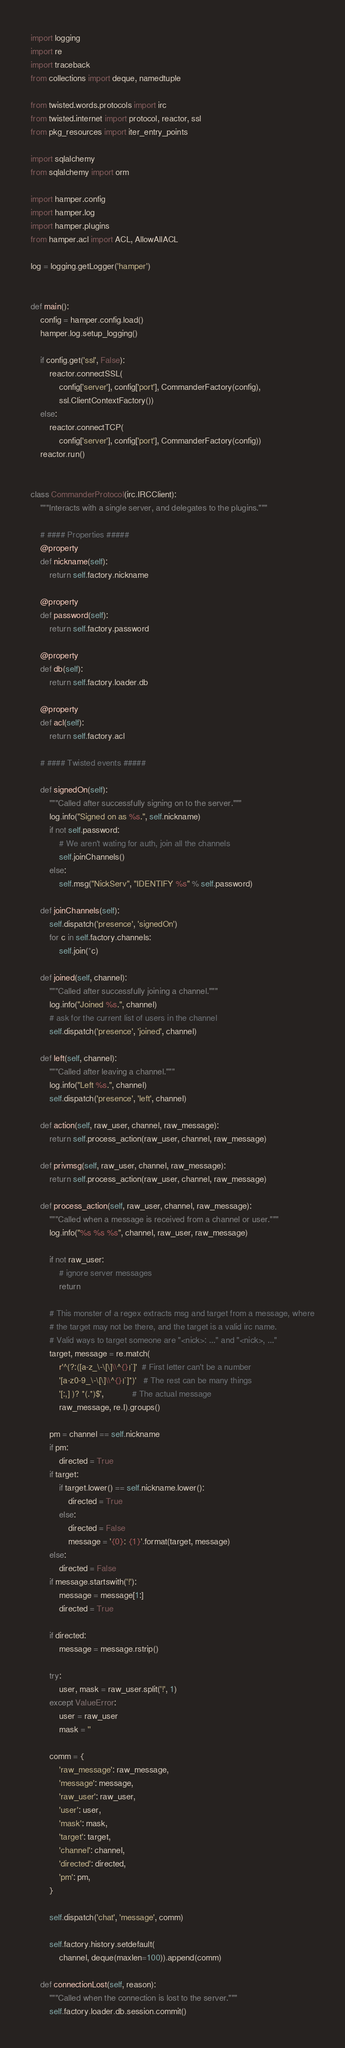Convert code to text. <code><loc_0><loc_0><loc_500><loc_500><_Python_>import logging
import re
import traceback
from collections import deque, namedtuple

from twisted.words.protocols import irc
from twisted.internet import protocol, reactor, ssl
from pkg_resources import iter_entry_points

import sqlalchemy
from sqlalchemy import orm

import hamper.config
import hamper.log
import hamper.plugins
from hamper.acl import ACL, AllowAllACL

log = logging.getLogger('hamper')


def main():
    config = hamper.config.load()
    hamper.log.setup_logging()

    if config.get('ssl', False):
        reactor.connectSSL(
            config['server'], config['port'], CommanderFactory(config),
            ssl.ClientContextFactory())
    else:
        reactor.connectTCP(
            config['server'], config['port'], CommanderFactory(config))
    reactor.run()


class CommanderProtocol(irc.IRCClient):
    """Interacts with a single server, and delegates to the plugins."""

    # #### Properties #####
    @property
    def nickname(self):
        return self.factory.nickname

    @property
    def password(self):
        return self.factory.password

    @property
    def db(self):
        return self.factory.loader.db

    @property
    def acl(self):
        return self.factory.acl

    # #### Twisted events #####

    def signedOn(self):
        """Called after successfully signing on to the server."""
        log.info("Signed on as %s.", self.nickname)
        if not self.password:
            # We aren't wating for auth, join all the channels
            self.joinChannels()
        else:
            self.msg("NickServ", "IDENTIFY %s" % self.password)

    def joinChannels(self):
        self.dispatch('presence', 'signedOn')
        for c in self.factory.channels:
            self.join(*c)

    def joined(self, channel):
        """Called after successfully joining a channel."""
        log.info("Joined %s.", channel)
        # ask for the current list of users in the channel
        self.dispatch('presence', 'joined', channel)

    def left(self, channel):
        """Called after leaving a channel."""
        log.info("Left %s.", channel)
        self.dispatch('presence', 'left', channel)

    def action(self, raw_user, channel, raw_message):
        return self.process_action(raw_user, channel, raw_message)

    def privmsg(self, raw_user, channel, raw_message):
        return self.process_action(raw_user, channel, raw_message)

    def process_action(self, raw_user, channel, raw_message):
        """Called when a message is received from a channel or user."""
        log.info("%s %s %s", channel, raw_user, raw_message)

        if not raw_user:
            # ignore server messages
            return

        # This monster of a regex extracts msg and target from a message, where
        # the target may not be there, and the target is a valid irc name.
        # Valid ways to target someone are "<nick>: ..." and "<nick>, ..."
        target, message = re.match(
            r'^(?:([a-z_\-\[\]\\^{}|`]'  # First letter can't be a number
            '[a-z0-9_\-\[\]\\^{}|`]*)'   # The rest can be many things
            '[:,] )? *(.*)$',            # The actual message
            raw_message, re.I).groups()

        pm = channel == self.nickname
        if pm:
            directed = True
        if target:
            if target.lower() == self.nickname.lower():
                directed = True
            else:
                directed = False
                message = '{0}: {1}'.format(target, message)
        else:
            directed = False
        if message.startswith('!'):
            message = message[1:]
            directed = True

        if directed:
            message = message.rstrip()

        try:
            user, mask = raw_user.split('!', 1)
        except ValueError:
            user = raw_user
            mask = ''

        comm = {
            'raw_message': raw_message,
            'message': message,
            'raw_user': raw_user,
            'user': user,
            'mask': mask,
            'target': target,
            'channel': channel,
            'directed': directed,
            'pm': pm,
        }

        self.dispatch('chat', 'message', comm)

        self.factory.history.setdefault(
            channel, deque(maxlen=100)).append(comm)

    def connectionLost(self, reason):
        """Called when the connection is lost to the server."""
        self.factory.loader.db.session.commit()</code> 